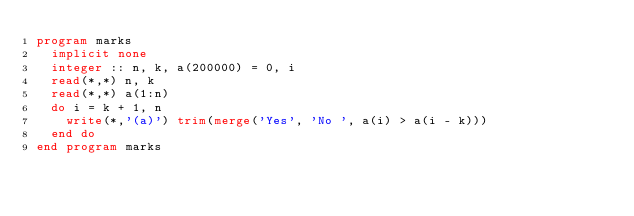Convert code to text. <code><loc_0><loc_0><loc_500><loc_500><_FORTRAN_>program marks
  implicit none
  integer :: n, k, a(200000) = 0, i
  read(*,*) n, k
  read(*,*) a(1:n)
  do i = k + 1, n
    write(*,'(a)') trim(merge('Yes', 'No ', a(i) > a(i - k)))
  end do
end program marks</code> 